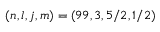<formula> <loc_0><loc_0><loc_500><loc_500>( n , l , j , m ) = ( 9 9 , 3 , 5 / 2 , 1 / 2 )</formula> 